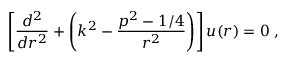Convert formula to latex. <formula><loc_0><loc_0><loc_500><loc_500>\left [ \frac { d ^ { 2 } } { d r ^ { 2 } } + \left ( k ^ { 2 } - \frac { p ^ { 2 } - 1 / 4 } { r ^ { 2 } } \right ) \right ] u ( r ) = 0 \, ,</formula> 